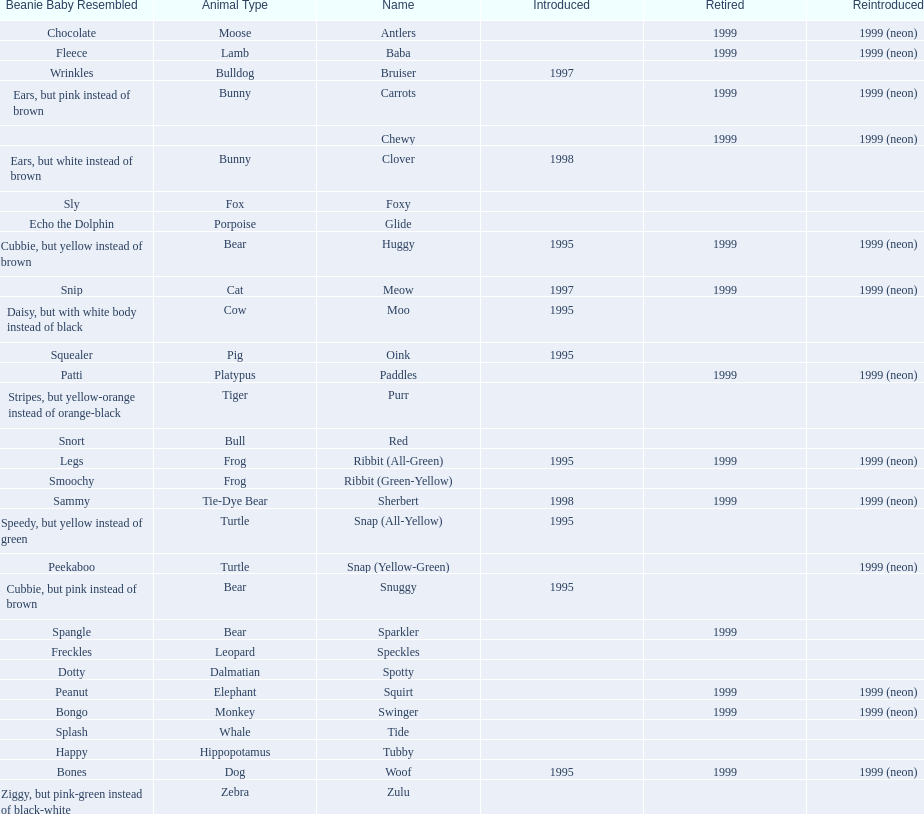What are the types of pillow pal animals? Antlers, Moose, Lamb, Bulldog, Bunny, , Bunny, Fox, Porpoise, Bear, Cat, Cow, Pig, Platypus, Tiger, Bull, Frog, Frog, Tie-Dye Bear, Turtle, Turtle, Bear, Bear, Leopard, Dalmatian, Elephant, Monkey, Whale, Hippopotamus, Dog, Zebra. Of those, which is a dalmatian? Dalmatian. What is the name of the dalmatian? Spotty. 